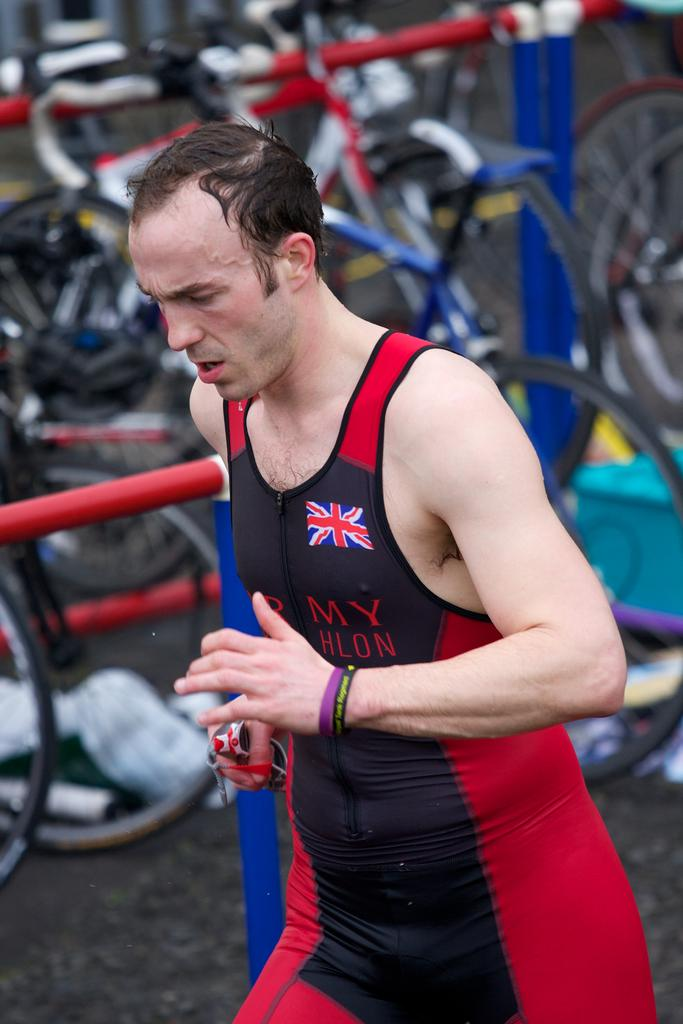Who is the main subject in the front of the image? There is a man in the front of the image. What can be seen in the background of the image? There are bicycles in the background of the image. How would you describe the background of the image? The background is slightly blurred. Reasoning: Let's think step by following the guidelines to produce the conversation. We start by identifying the main subject in the image, which is the man. Then, we expand the conversation to include other elements in the image, such as the bicycles in the background. Finally, we describe the background's appearance, noting that it is slightly blurred. Absurd Question/Answer: What type of throne is the man sitting on in the image? There is no throne present in the image; the man is standing in the front. What is the man using to cough in the image? There is no coughing or use of scissors in the image. 